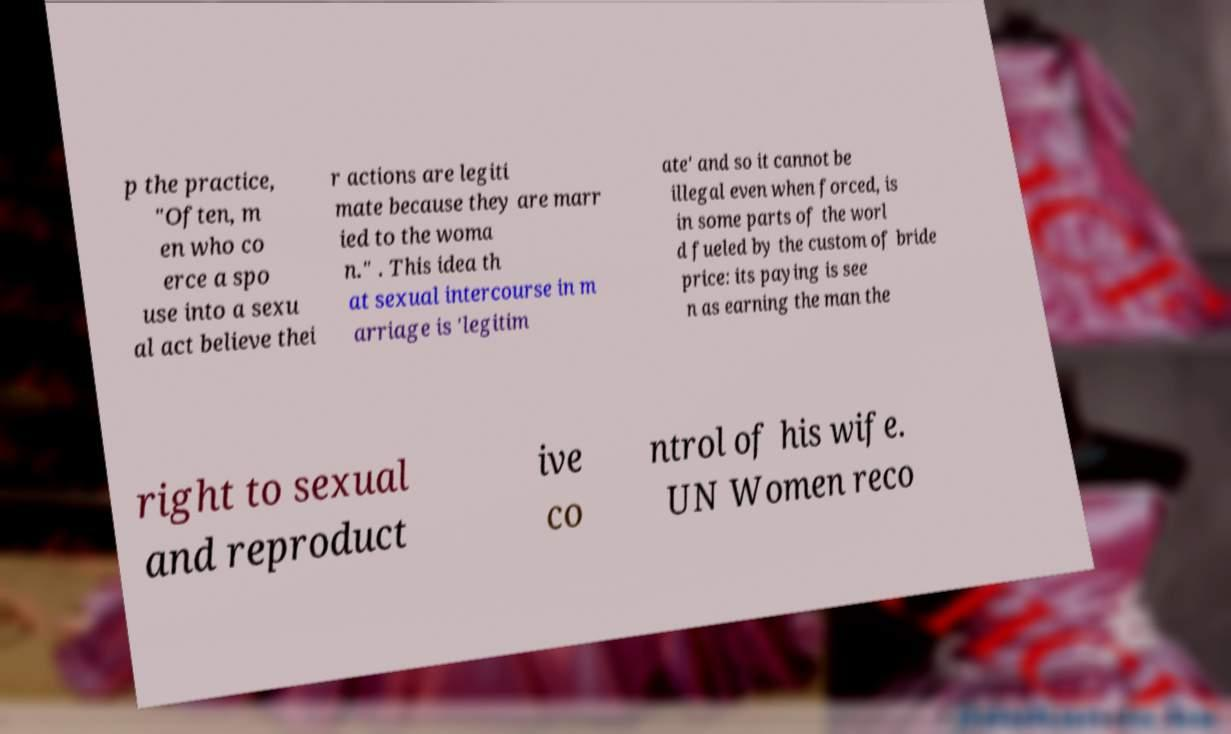What messages or text are displayed in this image? I need them in a readable, typed format. p the practice, "Often, m en who co erce a spo use into a sexu al act believe thei r actions are legiti mate because they are marr ied to the woma n." . This idea th at sexual intercourse in m arriage is 'legitim ate' and so it cannot be illegal even when forced, is in some parts of the worl d fueled by the custom of bride price: its paying is see n as earning the man the right to sexual and reproduct ive co ntrol of his wife. UN Women reco 